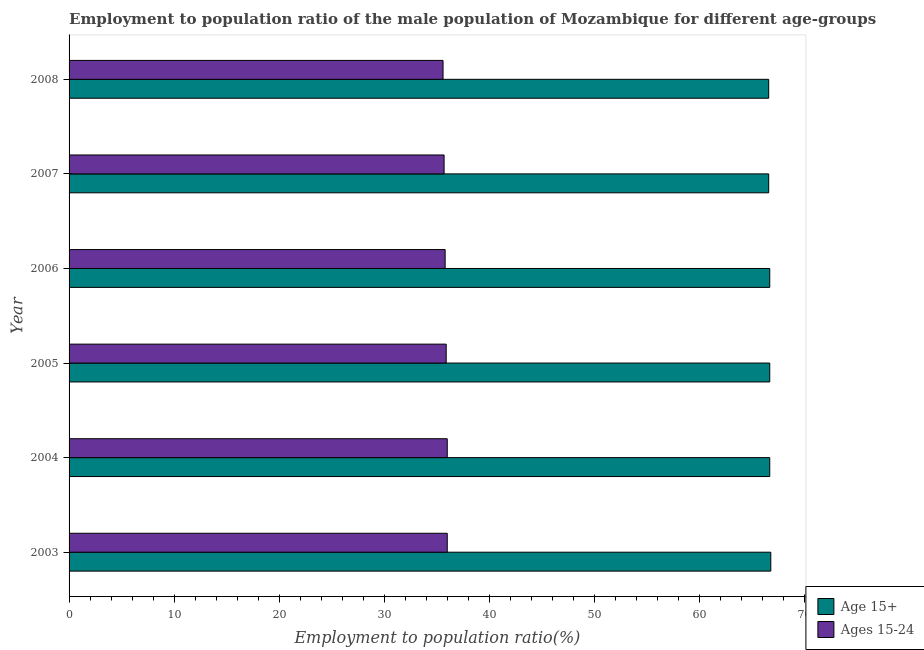How many groups of bars are there?
Your response must be concise. 6. Are the number of bars per tick equal to the number of legend labels?
Keep it short and to the point. Yes. Are the number of bars on each tick of the Y-axis equal?
Your answer should be compact. Yes. What is the label of the 3rd group of bars from the top?
Give a very brief answer. 2006. What is the employment to population ratio(age 15-24) in 2008?
Offer a terse response. 35.6. Across all years, what is the maximum employment to population ratio(age 15+)?
Give a very brief answer. 66.8. Across all years, what is the minimum employment to population ratio(age 15+)?
Offer a very short reply. 66.6. What is the total employment to population ratio(age 15+) in the graph?
Offer a terse response. 400.1. What is the difference between the employment to population ratio(age 15+) in 2006 and the employment to population ratio(age 15-24) in 2005?
Keep it short and to the point. 30.8. What is the average employment to population ratio(age 15-24) per year?
Offer a very short reply. 35.83. In the year 2005, what is the difference between the employment to population ratio(age 15+) and employment to population ratio(age 15-24)?
Your response must be concise. 30.8. In how many years, is the employment to population ratio(age 15+) greater than 4 %?
Offer a very short reply. 6. What is the ratio of the employment to population ratio(age 15-24) in 2004 to that in 2005?
Provide a short and direct response. 1. Is the employment to population ratio(age 15+) in 2004 less than that in 2005?
Ensure brevity in your answer.  No. What is the difference between the highest and the lowest employment to population ratio(age 15-24)?
Your response must be concise. 0.4. Is the sum of the employment to population ratio(age 15-24) in 2006 and 2008 greater than the maximum employment to population ratio(age 15+) across all years?
Keep it short and to the point. Yes. What does the 1st bar from the top in 2003 represents?
Provide a short and direct response. Ages 15-24. What does the 2nd bar from the bottom in 2007 represents?
Make the answer very short. Ages 15-24. Are all the bars in the graph horizontal?
Your answer should be compact. Yes. How many years are there in the graph?
Ensure brevity in your answer.  6. What is the difference between two consecutive major ticks on the X-axis?
Provide a succinct answer. 10. Does the graph contain any zero values?
Provide a short and direct response. No. Where does the legend appear in the graph?
Your response must be concise. Bottom right. What is the title of the graph?
Make the answer very short. Employment to population ratio of the male population of Mozambique for different age-groups. Does "Netherlands" appear as one of the legend labels in the graph?
Your answer should be very brief. No. What is the label or title of the X-axis?
Give a very brief answer. Employment to population ratio(%). What is the label or title of the Y-axis?
Ensure brevity in your answer.  Year. What is the Employment to population ratio(%) in Age 15+ in 2003?
Your response must be concise. 66.8. What is the Employment to population ratio(%) in Ages 15-24 in 2003?
Make the answer very short. 36. What is the Employment to population ratio(%) of Age 15+ in 2004?
Keep it short and to the point. 66.7. What is the Employment to population ratio(%) of Age 15+ in 2005?
Provide a short and direct response. 66.7. What is the Employment to population ratio(%) of Ages 15-24 in 2005?
Give a very brief answer. 35.9. What is the Employment to population ratio(%) of Age 15+ in 2006?
Ensure brevity in your answer.  66.7. What is the Employment to population ratio(%) of Ages 15-24 in 2006?
Your response must be concise. 35.8. What is the Employment to population ratio(%) in Age 15+ in 2007?
Your response must be concise. 66.6. What is the Employment to population ratio(%) in Ages 15-24 in 2007?
Your response must be concise. 35.7. What is the Employment to population ratio(%) in Age 15+ in 2008?
Keep it short and to the point. 66.6. What is the Employment to population ratio(%) in Ages 15-24 in 2008?
Offer a very short reply. 35.6. Across all years, what is the maximum Employment to population ratio(%) of Age 15+?
Offer a terse response. 66.8. Across all years, what is the minimum Employment to population ratio(%) in Age 15+?
Keep it short and to the point. 66.6. Across all years, what is the minimum Employment to population ratio(%) in Ages 15-24?
Offer a terse response. 35.6. What is the total Employment to population ratio(%) of Age 15+ in the graph?
Ensure brevity in your answer.  400.1. What is the total Employment to population ratio(%) in Ages 15-24 in the graph?
Give a very brief answer. 215. What is the difference between the Employment to population ratio(%) of Age 15+ in 2003 and that in 2005?
Keep it short and to the point. 0.1. What is the difference between the Employment to population ratio(%) in Ages 15-24 in 2003 and that in 2005?
Your answer should be very brief. 0.1. What is the difference between the Employment to population ratio(%) of Ages 15-24 in 2003 and that in 2007?
Your answer should be very brief. 0.3. What is the difference between the Employment to population ratio(%) in Age 15+ in 2003 and that in 2008?
Keep it short and to the point. 0.2. What is the difference between the Employment to population ratio(%) of Ages 15-24 in 2004 and that in 2006?
Your response must be concise. 0.2. What is the difference between the Employment to population ratio(%) of Age 15+ in 2004 and that in 2007?
Your response must be concise. 0.1. What is the difference between the Employment to population ratio(%) in Ages 15-24 in 2004 and that in 2008?
Your answer should be compact. 0.4. What is the difference between the Employment to population ratio(%) of Age 15+ in 2005 and that in 2007?
Offer a terse response. 0.1. What is the difference between the Employment to population ratio(%) of Ages 15-24 in 2006 and that in 2008?
Give a very brief answer. 0.2. What is the difference between the Employment to population ratio(%) in Age 15+ in 2003 and the Employment to population ratio(%) in Ages 15-24 in 2004?
Ensure brevity in your answer.  30.8. What is the difference between the Employment to population ratio(%) of Age 15+ in 2003 and the Employment to population ratio(%) of Ages 15-24 in 2005?
Offer a terse response. 30.9. What is the difference between the Employment to population ratio(%) in Age 15+ in 2003 and the Employment to population ratio(%) in Ages 15-24 in 2007?
Provide a succinct answer. 31.1. What is the difference between the Employment to population ratio(%) in Age 15+ in 2003 and the Employment to population ratio(%) in Ages 15-24 in 2008?
Provide a short and direct response. 31.2. What is the difference between the Employment to population ratio(%) of Age 15+ in 2004 and the Employment to population ratio(%) of Ages 15-24 in 2005?
Ensure brevity in your answer.  30.8. What is the difference between the Employment to population ratio(%) in Age 15+ in 2004 and the Employment to population ratio(%) in Ages 15-24 in 2006?
Your response must be concise. 30.9. What is the difference between the Employment to population ratio(%) of Age 15+ in 2004 and the Employment to population ratio(%) of Ages 15-24 in 2007?
Keep it short and to the point. 31. What is the difference between the Employment to population ratio(%) of Age 15+ in 2004 and the Employment to population ratio(%) of Ages 15-24 in 2008?
Give a very brief answer. 31.1. What is the difference between the Employment to population ratio(%) in Age 15+ in 2005 and the Employment to population ratio(%) in Ages 15-24 in 2006?
Your answer should be very brief. 30.9. What is the difference between the Employment to population ratio(%) in Age 15+ in 2005 and the Employment to population ratio(%) in Ages 15-24 in 2007?
Provide a succinct answer. 31. What is the difference between the Employment to population ratio(%) of Age 15+ in 2005 and the Employment to population ratio(%) of Ages 15-24 in 2008?
Your response must be concise. 31.1. What is the difference between the Employment to population ratio(%) in Age 15+ in 2006 and the Employment to population ratio(%) in Ages 15-24 in 2008?
Provide a succinct answer. 31.1. What is the difference between the Employment to population ratio(%) in Age 15+ in 2007 and the Employment to population ratio(%) in Ages 15-24 in 2008?
Ensure brevity in your answer.  31. What is the average Employment to population ratio(%) in Age 15+ per year?
Ensure brevity in your answer.  66.68. What is the average Employment to population ratio(%) of Ages 15-24 per year?
Offer a terse response. 35.83. In the year 2003, what is the difference between the Employment to population ratio(%) in Age 15+ and Employment to population ratio(%) in Ages 15-24?
Provide a short and direct response. 30.8. In the year 2004, what is the difference between the Employment to population ratio(%) in Age 15+ and Employment to population ratio(%) in Ages 15-24?
Ensure brevity in your answer.  30.7. In the year 2005, what is the difference between the Employment to population ratio(%) in Age 15+ and Employment to population ratio(%) in Ages 15-24?
Provide a succinct answer. 30.8. In the year 2006, what is the difference between the Employment to population ratio(%) in Age 15+ and Employment to population ratio(%) in Ages 15-24?
Provide a succinct answer. 30.9. In the year 2007, what is the difference between the Employment to population ratio(%) of Age 15+ and Employment to population ratio(%) of Ages 15-24?
Your answer should be compact. 30.9. What is the ratio of the Employment to population ratio(%) in Ages 15-24 in 2003 to that in 2006?
Keep it short and to the point. 1.01. What is the ratio of the Employment to population ratio(%) of Age 15+ in 2003 to that in 2007?
Your answer should be compact. 1. What is the ratio of the Employment to population ratio(%) of Ages 15-24 in 2003 to that in 2007?
Give a very brief answer. 1.01. What is the ratio of the Employment to population ratio(%) of Ages 15-24 in 2003 to that in 2008?
Give a very brief answer. 1.01. What is the ratio of the Employment to population ratio(%) in Age 15+ in 2004 to that in 2005?
Make the answer very short. 1. What is the ratio of the Employment to population ratio(%) in Ages 15-24 in 2004 to that in 2005?
Provide a succinct answer. 1. What is the ratio of the Employment to population ratio(%) of Ages 15-24 in 2004 to that in 2006?
Your answer should be very brief. 1.01. What is the ratio of the Employment to population ratio(%) in Age 15+ in 2004 to that in 2007?
Keep it short and to the point. 1. What is the ratio of the Employment to population ratio(%) of Ages 15-24 in 2004 to that in 2007?
Make the answer very short. 1.01. What is the ratio of the Employment to population ratio(%) in Age 15+ in 2004 to that in 2008?
Offer a very short reply. 1. What is the ratio of the Employment to population ratio(%) of Ages 15-24 in 2004 to that in 2008?
Your response must be concise. 1.01. What is the ratio of the Employment to population ratio(%) in Ages 15-24 in 2005 to that in 2006?
Ensure brevity in your answer.  1. What is the ratio of the Employment to population ratio(%) of Age 15+ in 2005 to that in 2007?
Your answer should be very brief. 1. What is the ratio of the Employment to population ratio(%) in Ages 15-24 in 2005 to that in 2007?
Offer a very short reply. 1.01. What is the ratio of the Employment to population ratio(%) in Ages 15-24 in 2005 to that in 2008?
Give a very brief answer. 1.01. What is the ratio of the Employment to population ratio(%) in Ages 15-24 in 2006 to that in 2007?
Provide a succinct answer. 1. What is the ratio of the Employment to population ratio(%) of Ages 15-24 in 2006 to that in 2008?
Your response must be concise. 1.01. What is the difference between the highest and the second highest Employment to population ratio(%) of Age 15+?
Offer a very short reply. 0.1. What is the difference between the highest and the second highest Employment to population ratio(%) of Ages 15-24?
Your answer should be compact. 0. What is the difference between the highest and the lowest Employment to population ratio(%) of Age 15+?
Give a very brief answer. 0.2. 